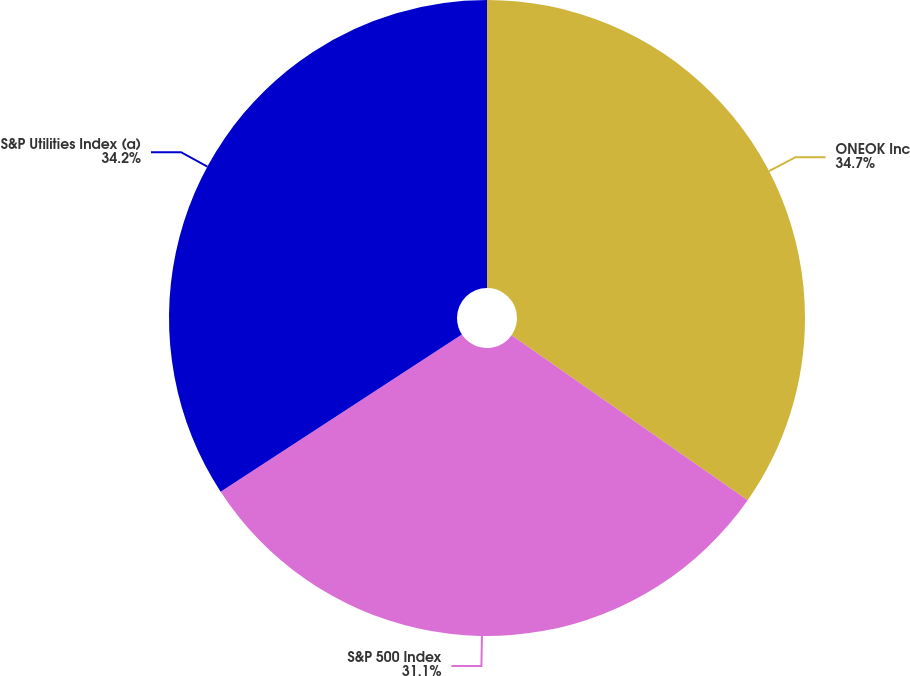<chart> <loc_0><loc_0><loc_500><loc_500><pie_chart><fcel>ONEOK Inc<fcel>S&P 500 Index<fcel>S&P Utilities Index (a)<nl><fcel>34.71%<fcel>31.1%<fcel>34.2%<nl></chart> 